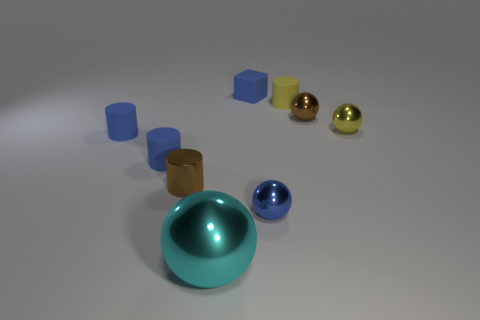Is there anything else that has the same material as the large ball?
Ensure brevity in your answer.  Yes. How many things are either tiny brown objects that are behind the small brown cylinder or green metallic objects?
Keep it short and to the point. 1. Are there the same number of small yellow matte cylinders in front of the brown cylinder and matte blocks that are to the left of the matte cube?
Provide a short and direct response. Yes. How many other objects are there of the same shape as the cyan shiny object?
Provide a succinct answer. 3. Do the brown object that is on the left side of the big cyan thing and the rubber object that is right of the blue cube have the same size?
Give a very brief answer. Yes. How many blocks are either yellow metal things or tiny yellow objects?
Your response must be concise. 0. How many metallic objects are tiny green spheres or tiny blocks?
Provide a succinct answer. 0. There is a blue object that is the same shape as the yellow shiny thing; what size is it?
Make the answer very short. Small. Are there any other things that are the same size as the block?
Provide a succinct answer. Yes. There is a metallic cylinder; does it have the same size as the brown thing that is right of the blue shiny object?
Give a very brief answer. Yes. 